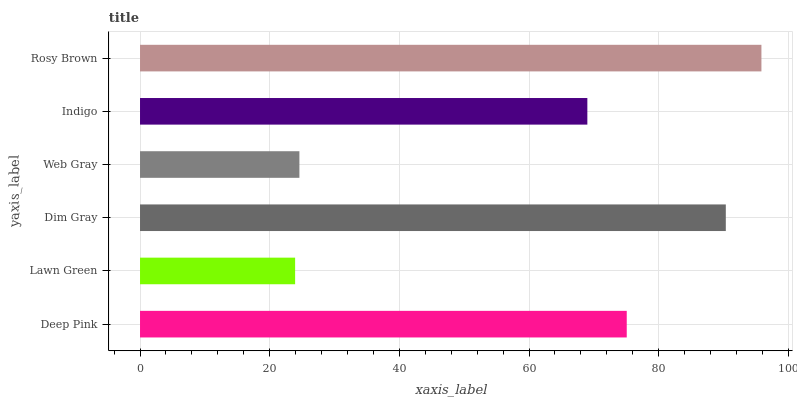Is Lawn Green the minimum?
Answer yes or no. Yes. Is Rosy Brown the maximum?
Answer yes or no. Yes. Is Dim Gray the minimum?
Answer yes or no. No. Is Dim Gray the maximum?
Answer yes or no. No. Is Dim Gray greater than Lawn Green?
Answer yes or no. Yes. Is Lawn Green less than Dim Gray?
Answer yes or no. Yes. Is Lawn Green greater than Dim Gray?
Answer yes or no. No. Is Dim Gray less than Lawn Green?
Answer yes or no. No. Is Deep Pink the high median?
Answer yes or no. Yes. Is Indigo the low median?
Answer yes or no. Yes. Is Rosy Brown the high median?
Answer yes or no. No. Is Dim Gray the low median?
Answer yes or no. No. 